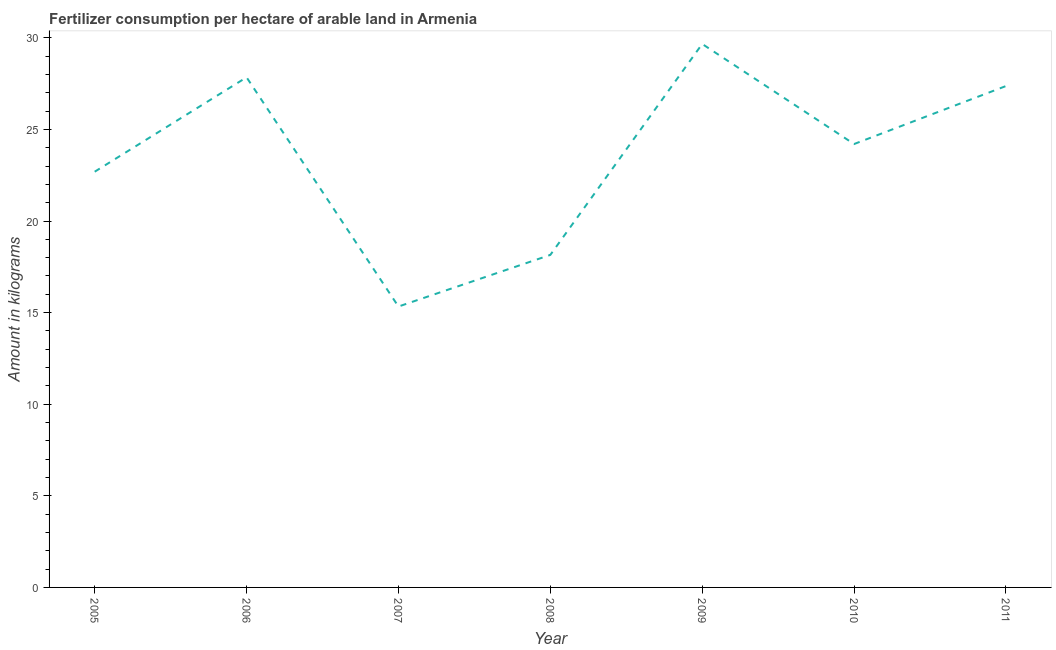What is the amount of fertilizer consumption in 2010?
Give a very brief answer. 24.2. Across all years, what is the maximum amount of fertilizer consumption?
Provide a short and direct response. 29.67. Across all years, what is the minimum amount of fertilizer consumption?
Keep it short and to the point. 15.33. What is the sum of the amount of fertilizer consumption?
Provide a succinct answer. 165.26. What is the difference between the amount of fertilizer consumption in 2006 and 2010?
Provide a succinct answer. 3.64. What is the average amount of fertilizer consumption per year?
Provide a short and direct response. 23.61. What is the median amount of fertilizer consumption?
Make the answer very short. 24.2. In how many years, is the amount of fertilizer consumption greater than 1 kg?
Provide a succinct answer. 7. What is the ratio of the amount of fertilizer consumption in 2006 to that in 2010?
Keep it short and to the point. 1.15. Is the amount of fertilizer consumption in 2006 less than that in 2008?
Offer a terse response. No. Is the difference between the amount of fertilizer consumption in 2007 and 2010 greater than the difference between any two years?
Make the answer very short. No. What is the difference between the highest and the second highest amount of fertilizer consumption?
Provide a short and direct response. 1.82. What is the difference between the highest and the lowest amount of fertilizer consumption?
Your answer should be very brief. 14.33. In how many years, is the amount of fertilizer consumption greater than the average amount of fertilizer consumption taken over all years?
Provide a succinct answer. 4. Does the amount of fertilizer consumption monotonically increase over the years?
Your answer should be very brief. No. Are the values on the major ticks of Y-axis written in scientific E-notation?
Provide a short and direct response. No. Does the graph contain grids?
Offer a very short reply. No. What is the title of the graph?
Your response must be concise. Fertilizer consumption per hectare of arable land in Armenia . What is the label or title of the Y-axis?
Your response must be concise. Amount in kilograms. What is the Amount in kilograms in 2005?
Offer a very short reply. 22.69. What is the Amount in kilograms in 2006?
Make the answer very short. 27.84. What is the Amount in kilograms of 2007?
Make the answer very short. 15.33. What is the Amount in kilograms in 2008?
Offer a terse response. 18.15. What is the Amount in kilograms of 2009?
Your response must be concise. 29.67. What is the Amount in kilograms in 2010?
Provide a succinct answer. 24.2. What is the Amount in kilograms of 2011?
Ensure brevity in your answer.  27.37. What is the difference between the Amount in kilograms in 2005 and 2006?
Your answer should be compact. -5.15. What is the difference between the Amount in kilograms in 2005 and 2007?
Offer a terse response. 7.36. What is the difference between the Amount in kilograms in 2005 and 2008?
Give a very brief answer. 4.54. What is the difference between the Amount in kilograms in 2005 and 2009?
Your answer should be very brief. -6.97. What is the difference between the Amount in kilograms in 2005 and 2010?
Provide a short and direct response. -1.51. What is the difference between the Amount in kilograms in 2005 and 2011?
Your answer should be very brief. -4.68. What is the difference between the Amount in kilograms in 2006 and 2007?
Your response must be concise. 12.51. What is the difference between the Amount in kilograms in 2006 and 2008?
Offer a very short reply. 9.69. What is the difference between the Amount in kilograms in 2006 and 2009?
Offer a terse response. -1.82. What is the difference between the Amount in kilograms in 2006 and 2010?
Keep it short and to the point. 3.64. What is the difference between the Amount in kilograms in 2006 and 2011?
Ensure brevity in your answer.  0.48. What is the difference between the Amount in kilograms in 2007 and 2008?
Keep it short and to the point. -2.82. What is the difference between the Amount in kilograms in 2007 and 2009?
Provide a succinct answer. -14.33. What is the difference between the Amount in kilograms in 2007 and 2010?
Offer a very short reply. -8.87. What is the difference between the Amount in kilograms in 2007 and 2011?
Make the answer very short. -12.04. What is the difference between the Amount in kilograms in 2008 and 2009?
Offer a terse response. -11.52. What is the difference between the Amount in kilograms in 2008 and 2010?
Give a very brief answer. -6.05. What is the difference between the Amount in kilograms in 2008 and 2011?
Your response must be concise. -9.22. What is the difference between the Amount in kilograms in 2009 and 2010?
Provide a short and direct response. 5.46. What is the difference between the Amount in kilograms in 2009 and 2011?
Provide a succinct answer. 2.3. What is the difference between the Amount in kilograms in 2010 and 2011?
Make the answer very short. -3.17. What is the ratio of the Amount in kilograms in 2005 to that in 2006?
Offer a terse response. 0.81. What is the ratio of the Amount in kilograms in 2005 to that in 2007?
Provide a short and direct response. 1.48. What is the ratio of the Amount in kilograms in 2005 to that in 2009?
Offer a terse response. 0.77. What is the ratio of the Amount in kilograms in 2005 to that in 2010?
Provide a short and direct response. 0.94. What is the ratio of the Amount in kilograms in 2005 to that in 2011?
Provide a succinct answer. 0.83. What is the ratio of the Amount in kilograms in 2006 to that in 2007?
Provide a short and direct response. 1.82. What is the ratio of the Amount in kilograms in 2006 to that in 2008?
Offer a terse response. 1.53. What is the ratio of the Amount in kilograms in 2006 to that in 2009?
Make the answer very short. 0.94. What is the ratio of the Amount in kilograms in 2006 to that in 2010?
Your response must be concise. 1.15. What is the ratio of the Amount in kilograms in 2007 to that in 2008?
Ensure brevity in your answer.  0.84. What is the ratio of the Amount in kilograms in 2007 to that in 2009?
Give a very brief answer. 0.52. What is the ratio of the Amount in kilograms in 2007 to that in 2010?
Provide a short and direct response. 0.63. What is the ratio of the Amount in kilograms in 2007 to that in 2011?
Give a very brief answer. 0.56. What is the ratio of the Amount in kilograms in 2008 to that in 2009?
Give a very brief answer. 0.61. What is the ratio of the Amount in kilograms in 2008 to that in 2011?
Keep it short and to the point. 0.66. What is the ratio of the Amount in kilograms in 2009 to that in 2010?
Provide a succinct answer. 1.23. What is the ratio of the Amount in kilograms in 2009 to that in 2011?
Ensure brevity in your answer.  1.08. What is the ratio of the Amount in kilograms in 2010 to that in 2011?
Offer a very short reply. 0.88. 